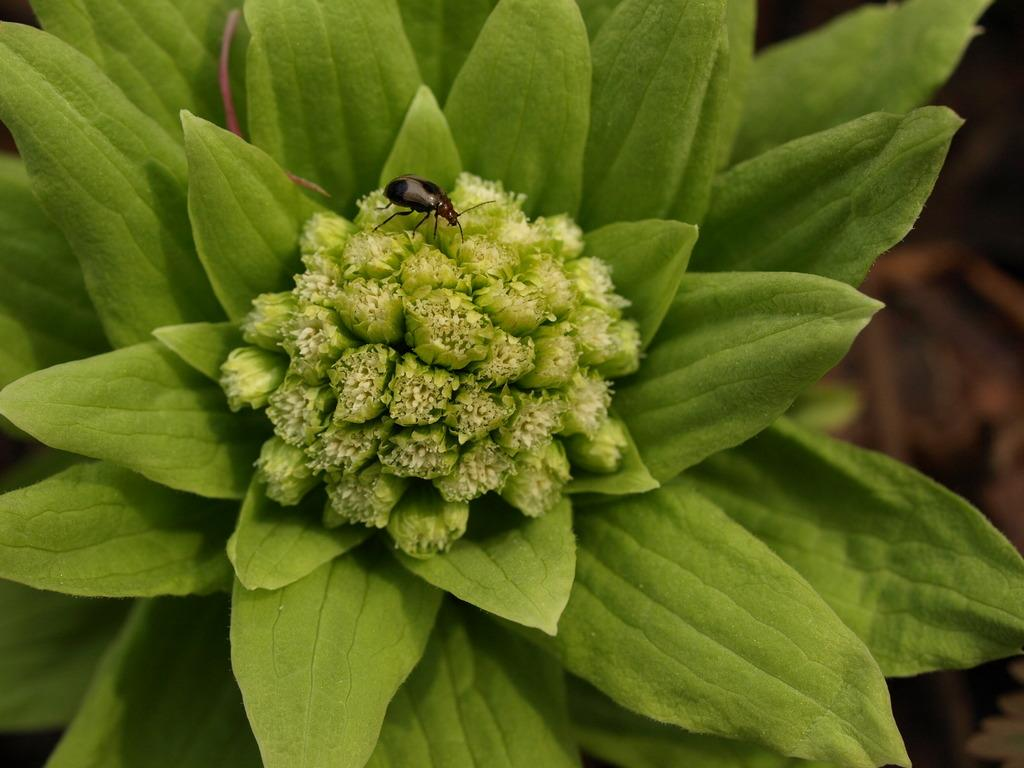What is located in the front of the image? There is a plant in the front of the image. What else can be seen in the image? There is an insect in the image. Can you describe the background of the image? The background of the image is blurry. Where is the cushion placed in the image? There is no cushion present in the image. What type of screw can be seen holding the insect in place? There is no screw present in the image, and the insect is not held in place. 